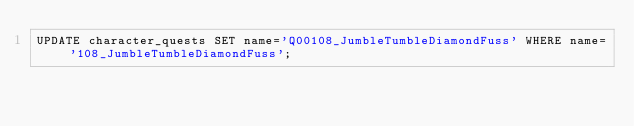<code> <loc_0><loc_0><loc_500><loc_500><_SQL_>UPDATE character_quests SET name='Q00108_JumbleTumbleDiamondFuss' WHERE name='108_JumbleTumbleDiamondFuss';</code> 